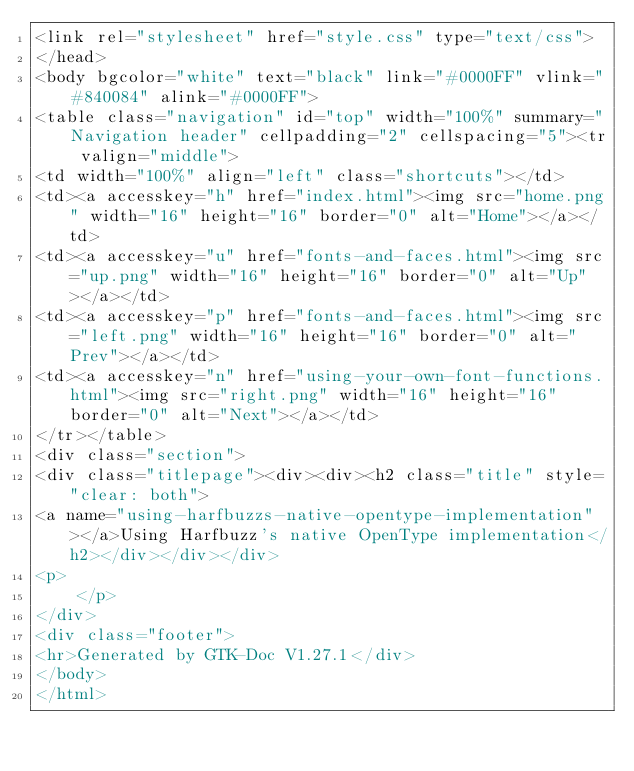Convert code to text. <code><loc_0><loc_0><loc_500><loc_500><_HTML_><link rel="stylesheet" href="style.css" type="text/css">
</head>
<body bgcolor="white" text="black" link="#0000FF" vlink="#840084" alink="#0000FF">
<table class="navigation" id="top" width="100%" summary="Navigation header" cellpadding="2" cellspacing="5"><tr valign="middle">
<td width="100%" align="left" class="shortcuts"></td>
<td><a accesskey="h" href="index.html"><img src="home.png" width="16" height="16" border="0" alt="Home"></a></td>
<td><a accesskey="u" href="fonts-and-faces.html"><img src="up.png" width="16" height="16" border="0" alt="Up"></a></td>
<td><a accesskey="p" href="fonts-and-faces.html"><img src="left.png" width="16" height="16" border="0" alt="Prev"></a></td>
<td><a accesskey="n" href="using-your-own-font-functions.html"><img src="right.png" width="16" height="16" border="0" alt="Next"></a></td>
</tr></table>
<div class="section">
<div class="titlepage"><div><div><h2 class="title" style="clear: both">
<a name="using-harfbuzzs-native-opentype-implementation"></a>Using Harfbuzz's native OpenType implementation</h2></div></div></div>
<p>
    </p>
</div>
<div class="footer">
<hr>Generated by GTK-Doc V1.27.1</div>
</body>
</html></code> 